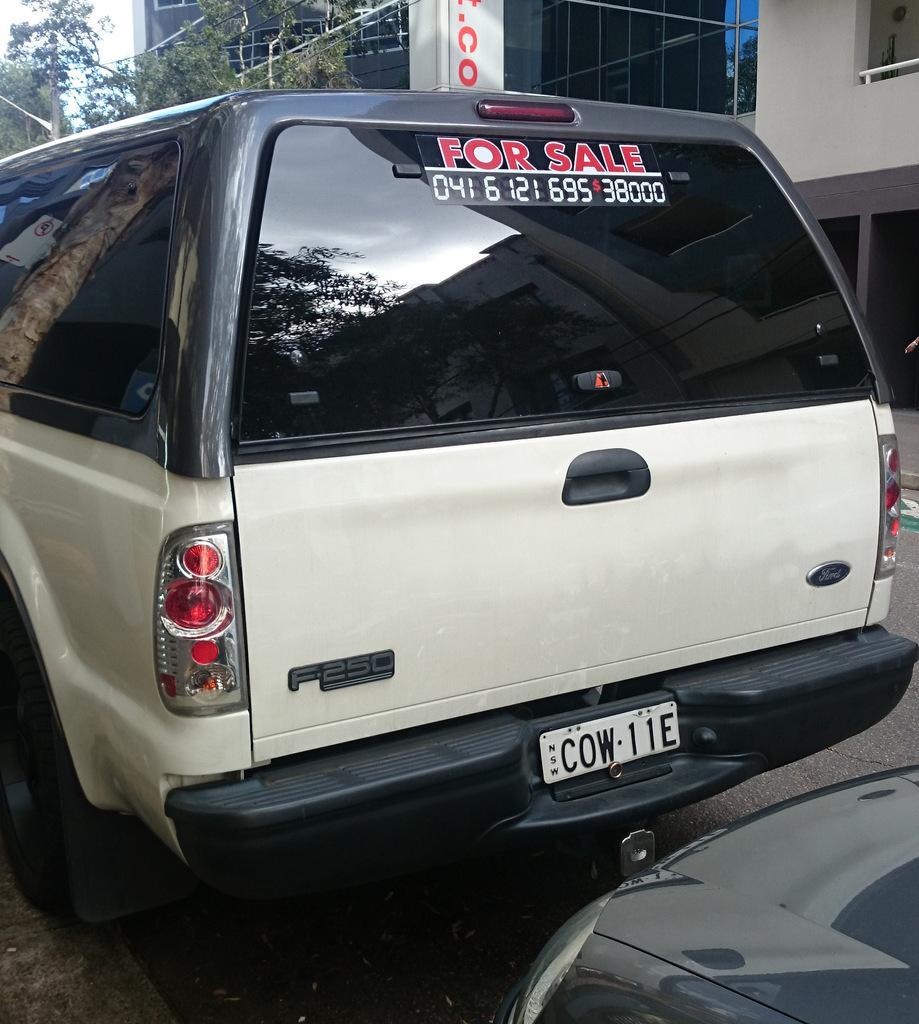Describe this image in one or two sentences. In this image we can see a vehicle. At the bottom of the image there is a road. On the right side of the image it looks like a vehicle. In the background of the image there are some buildings, trees and the sky. 